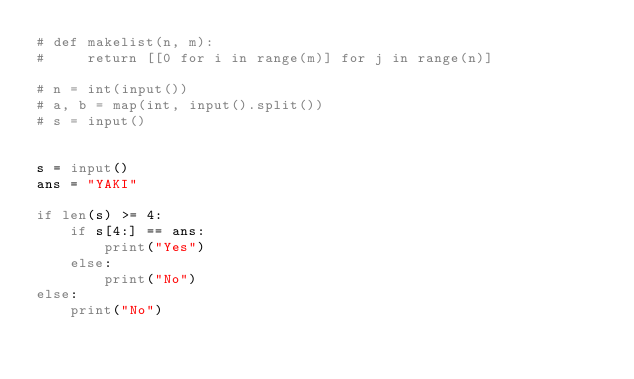Convert code to text. <code><loc_0><loc_0><loc_500><loc_500><_Python_># def makelist(n, m):
#     return [[0 for i in range(m)] for j in range(n)]

# n = int(input())
# a, b = map(int, input().split())
# s = input()

    
s = input()
ans = "YAKI"

if len(s) >= 4:
    if s[4:] == ans:
        print("Yes")
    else:
        print("No")
else:
    print("No")
</code> 